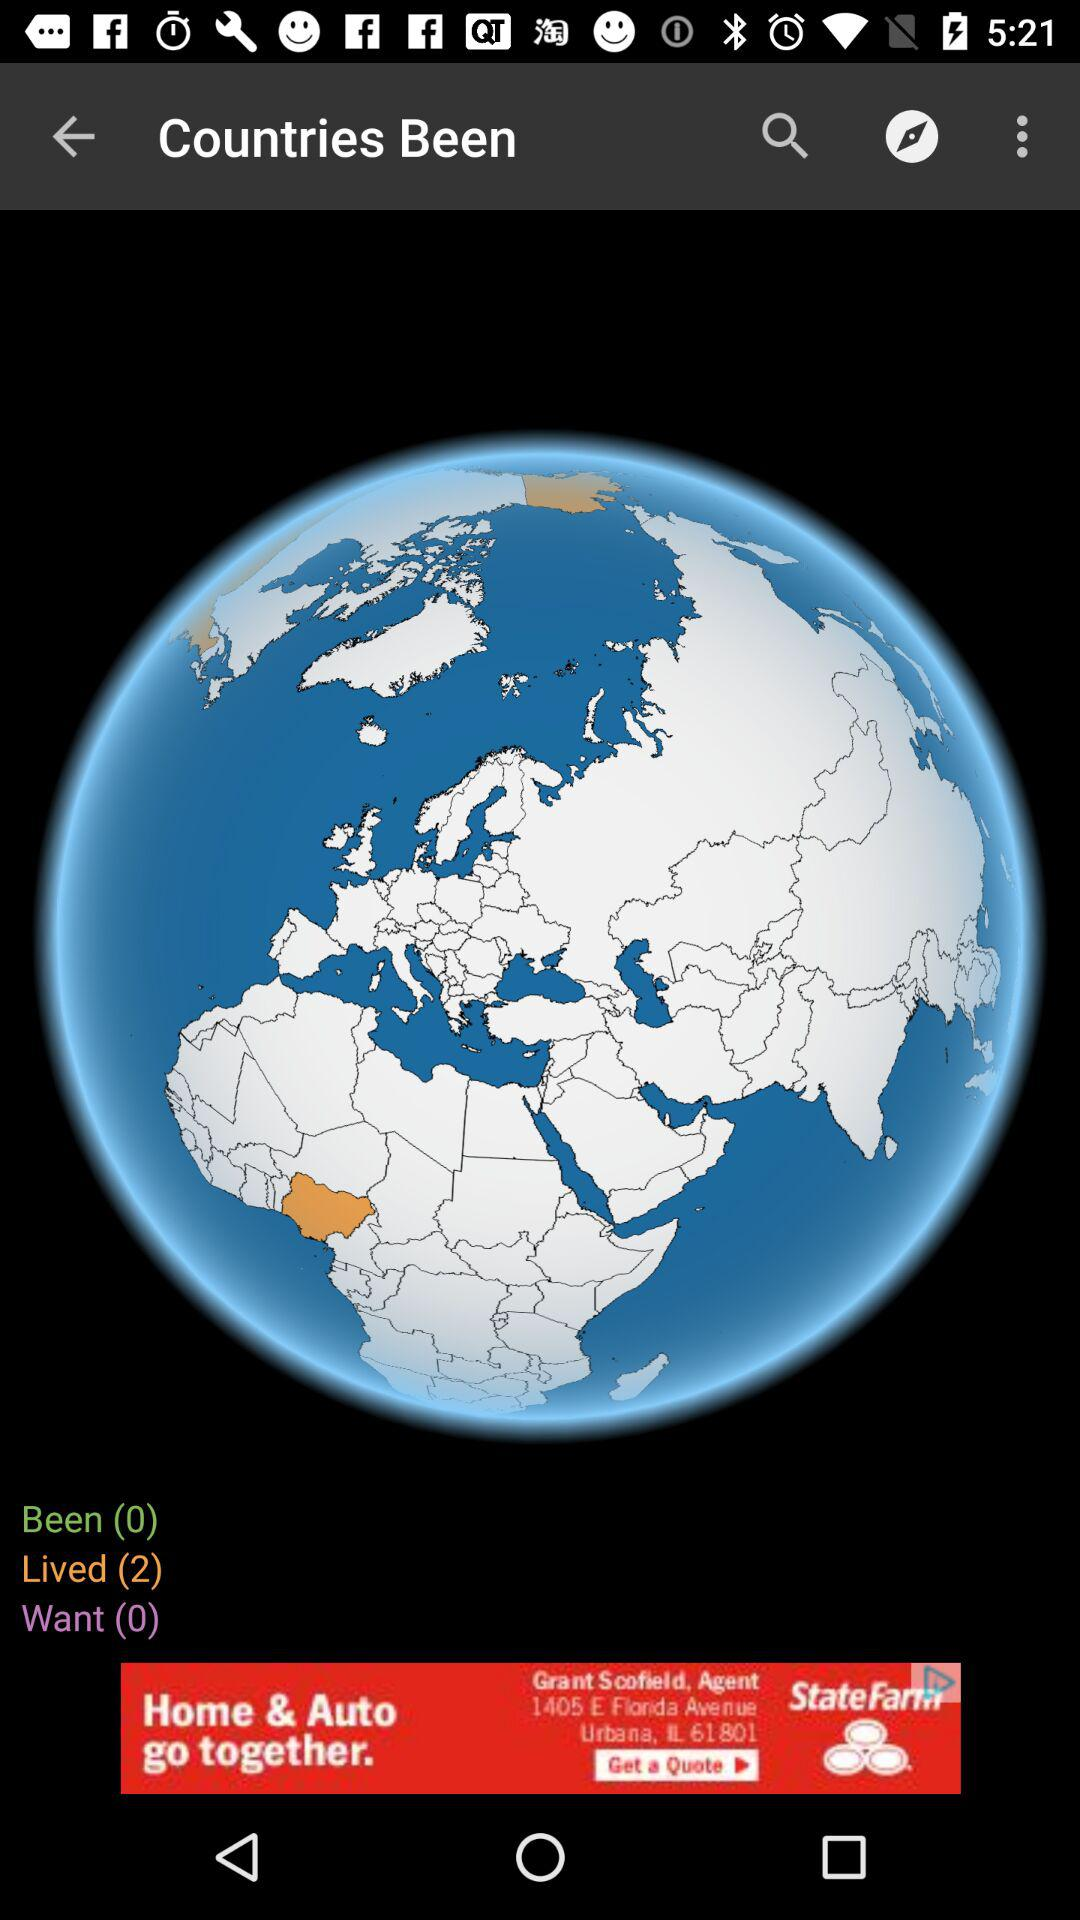How many "Been" are there? There are 0 "Been". 